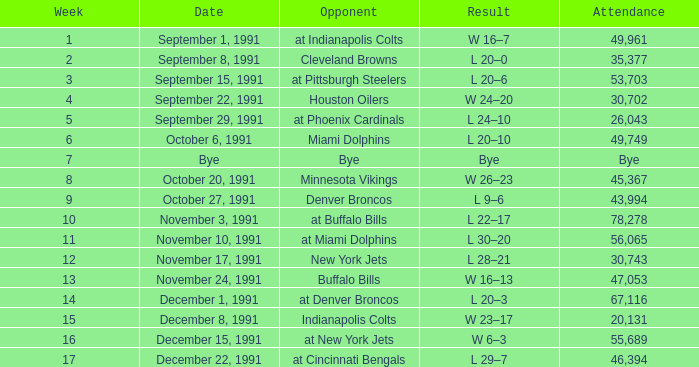Parse the table in full. {'header': ['Week', 'Date', 'Opponent', 'Result', 'Attendance'], 'rows': [['1', 'September 1, 1991', 'at Indianapolis Colts', 'W 16–7', '49,961'], ['2', 'September 8, 1991', 'Cleveland Browns', 'L 20–0', '35,377'], ['3', 'September 15, 1991', 'at Pittsburgh Steelers', 'L 20–6', '53,703'], ['4', 'September 22, 1991', 'Houston Oilers', 'W 24–20', '30,702'], ['5', 'September 29, 1991', 'at Phoenix Cardinals', 'L 24–10', '26,043'], ['6', 'October 6, 1991', 'Miami Dolphins', 'L 20–10', '49,749'], ['7', 'Bye', 'Bye', 'Bye', 'Bye'], ['8', 'October 20, 1991', 'Minnesota Vikings', 'W 26–23', '45,367'], ['9', 'October 27, 1991', 'Denver Broncos', 'L 9–6', '43,994'], ['10', 'November 3, 1991', 'at Buffalo Bills', 'L 22–17', '78,278'], ['11', 'November 10, 1991', 'at Miami Dolphins', 'L 30–20', '56,065'], ['12', 'November 17, 1991', 'New York Jets', 'L 28–21', '30,743'], ['13', 'November 24, 1991', 'Buffalo Bills', 'W 16–13', '47,053'], ['14', 'December 1, 1991', 'at Denver Broncos', 'L 20–3', '67,116'], ['15', 'December 8, 1991', 'Indianapolis Colts', 'W 23–17', '20,131'], ['16', 'December 15, 1991', 'at New York Jets', 'W 6–3', '55,689'], ['17', 'December 22, 1991', 'at Cincinnati Bengals', 'L 29–7', '46,394']]} What was the result of the game on December 22, 1991? L 29–7. 